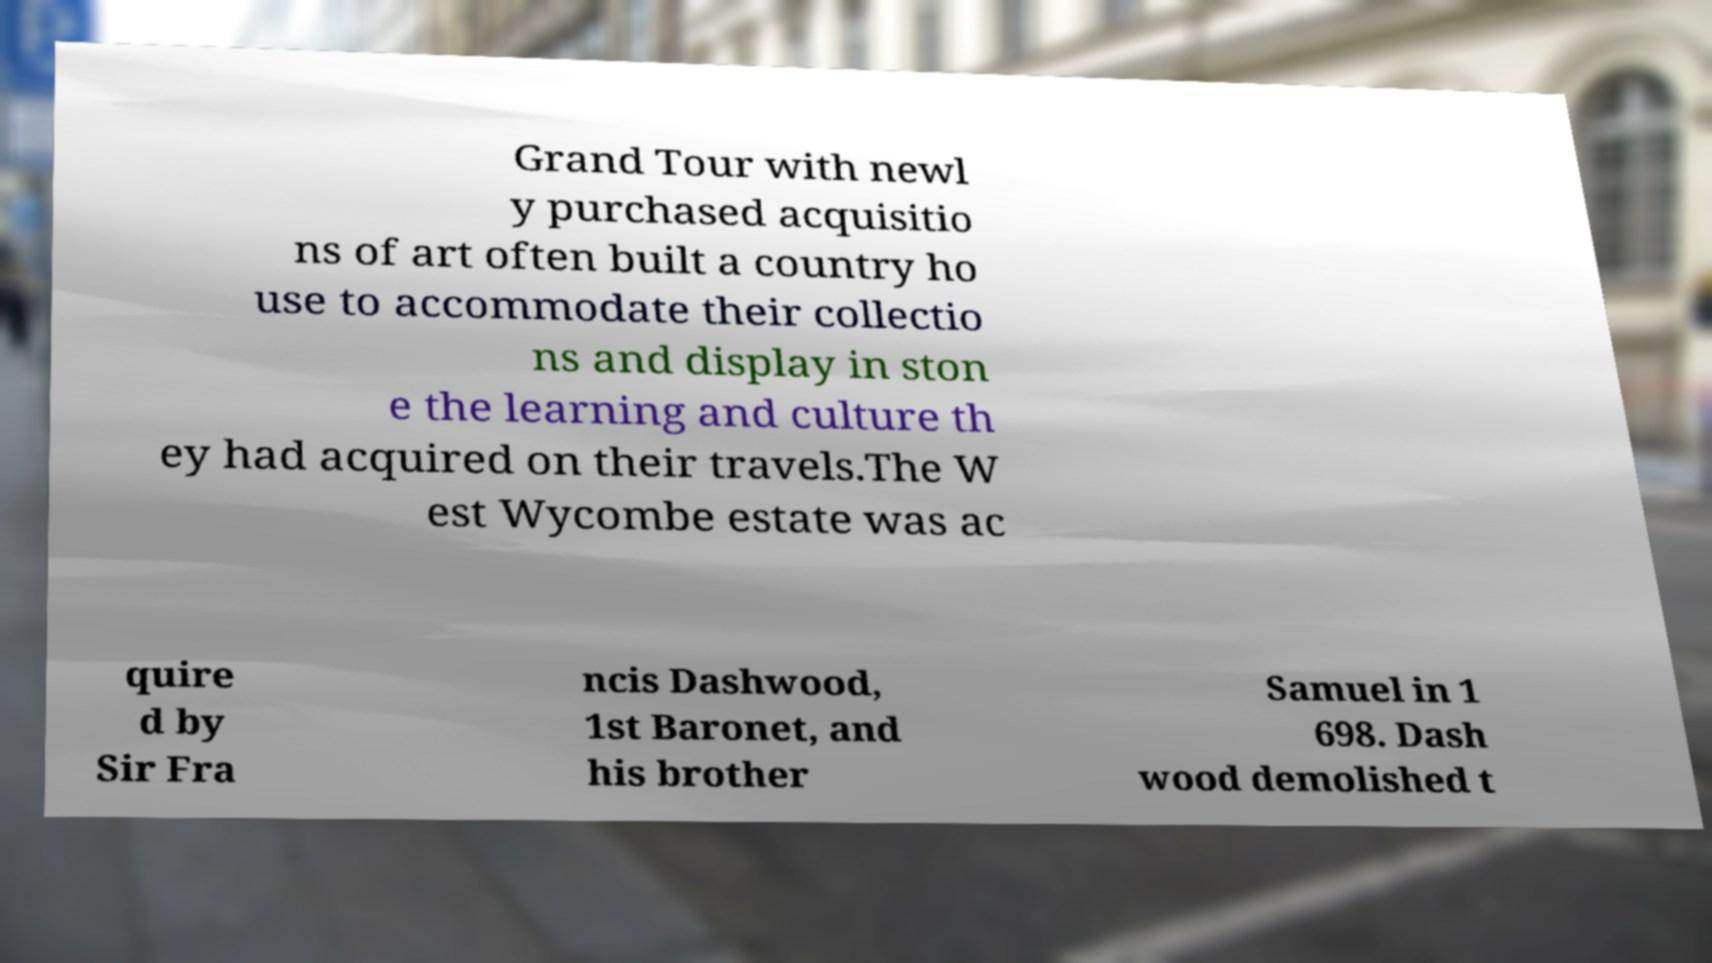Can you accurately transcribe the text from the provided image for me? Grand Tour with newl y purchased acquisitio ns of art often built a country ho use to accommodate their collectio ns and display in ston e the learning and culture th ey had acquired on their travels.The W est Wycombe estate was ac quire d by Sir Fra ncis Dashwood, 1st Baronet, and his brother Samuel in 1 698. Dash wood demolished t 